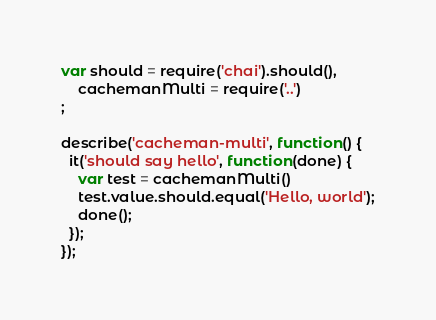Convert code to text. <code><loc_0><loc_0><loc_500><loc_500><_JavaScript_>var should = require('chai').should(),
    cachemanMulti = require('..')
;

describe('cacheman-multi', function() {
  it('should say hello', function(done) {
    var test = cachemanMulti()
    test.value.should.equal('Hello, world');
    done();
  });
});
</code> 